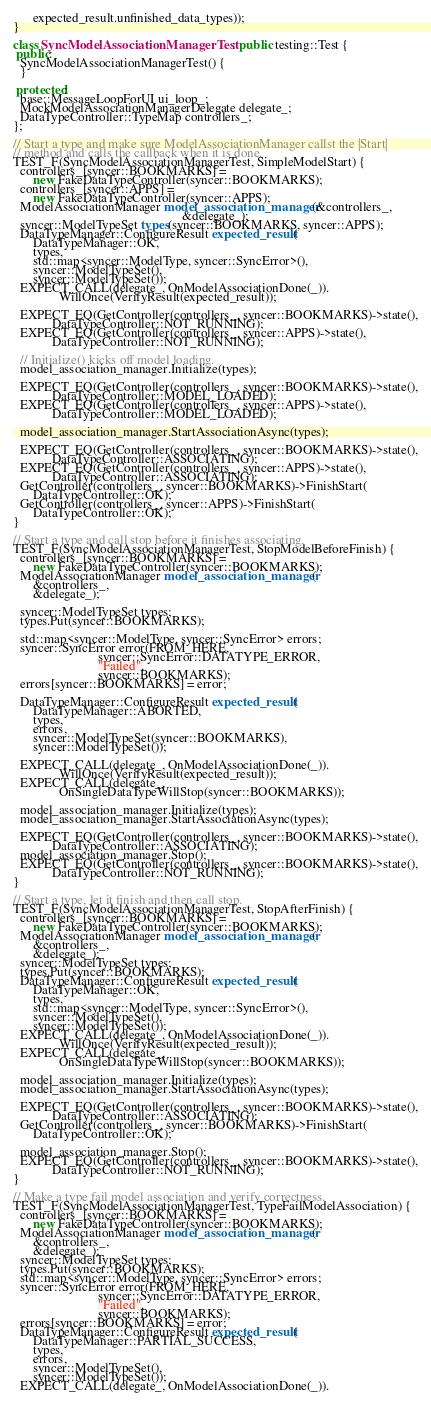Convert code to text. <code><loc_0><loc_0><loc_500><loc_500><_C++_>      expected_result.unfinished_data_types));
}

class SyncModelAssociationManagerTest : public testing::Test {
 public:
  SyncModelAssociationManagerTest() {
  }

 protected:
  base::MessageLoopForUI ui_loop_;
  MockModelAssociationManagerDelegate delegate_;
  DataTypeController::TypeMap controllers_;
};

// Start a type and make sure ModelAssociationManager callst the |Start|
// method and calls the callback when it is done.
TEST_F(SyncModelAssociationManagerTest, SimpleModelStart) {
  controllers_[syncer::BOOKMARKS] =
      new FakeDataTypeController(syncer::BOOKMARKS);
  controllers_[syncer::APPS] =
      new FakeDataTypeController(syncer::APPS);
  ModelAssociationManager model_association_manager(&controllers_,
                                                    &delegate_);
  syncer::ModelTypeSet types(syncer::BOOKMARKS, syncer::APPS);
  DataTypeManager::ConfigureResult expected_result(
      DataTypeManager::OK,
      types,
      std::map<syncer::ModelType, syncer::SyncError>(),
      syncer::ModelTypeSet(),
      syncer::ModelTypeSet());
  EXPECT_CALL(delegate_, OnModelAssociationDone(_)).
              WillOnce(VerifyResult(expected_result));

  EXPECT_EQ(GetController(controllers_, syncer::BOOKMARKS)->state(),
            DataTypeController::NOT_RUNNING);
  EXPECT_EQ(GetController(controllers_, syncer::APPS)->state(),
            DataTypeController::NOT_RUNNING);

  // Initialize() kicks off model loading.
  model_association_manager.Initialize(types);

  EXPECT_EQ(GetController(controllers_, syncer::BOOKMARKS)->state(),
            DataTypeController::MODEL_LOADED);
  EXPECT_EQ(GetController(controllers_, syncer::APPS)->state(),
            DataTypeController::MODEL_LOADED);

  model_association_manager.StartAssociationAsync(types);

  EXPECT_EQ(GetController(controllers_, syncer::BOOKMARKS)->state(),
            DataTypeController::ASSOCIATING);
  EXPECT_EQ(GetController(controllers_, syncer::APPS)->state(),
            DataTypeController::ASSOCIATING);
  GetController(controllers_, syncer::BOOKMARKS)->FinishStart(
      DataTypeController::OK);
  GetController(controllers_, syncer::APPS)->FinishStart(
      DataTypeController::OK);
}

// Start a type and call stop before it finishes associating.
TEST_F(SyncModelAssociationManagerTest, StopModelBeforeFinish) {
  controllers_[syncer::BOOKMARKS] =
      new FakeDataTypeController(syncer::BOOKMARKS);
  ModelAssociationManager model_association_manager(
      &controllers_,
      &delegate_);

  syncer::ModelTypeSet types;
  types.Put(syncer::BOOKMARKS);

  std::map<syncer::ModelType, syncer::SyncError> errors;
  syncer::SyncError error(FROM_HERE,
                          syncer::SyncError::DATATYPE_ERROR,
                          "Failed",
                          syncer::BOOKMARKS);
  errors[syncer::BOOKMARKS] = error;

  DataTypeManager::ConfigureResult expected_result(
      DataTypeManager::ABORTED,
      types,
      errors,
      syncer::ModelTypeSet(syncer::BOOKMARKS),
      syncer::ModelTypeSet());

  EXPECT_CALL(delegate_, OnModelAssociationDone(_)).
              WillOnce(VerifyResult(expected_result));
  EXPECT_CALL(delegate_,
              OnSingleDataTypeWillStop(syncer::BOOKMARKS));

  model_association_manager.Initialize(types);
  model_association_manager.StartAssociationAsync(types);

  EXPECT_EQ(GetController(controllers_, syncer::BOOKMARKS)->state(),
            DataTypeController::ASSOCIATING);
  model_association_manager.Stop();
  EXPECT_EQ(GetController(controllers_, syncer::BOOKMARKS)->state(),
            DataTypeController::NOT_RUNNING);
}

// Start a type, let it finish and then call stop.
TEST_F(SyncModelAssociationManagerTest, StopAfterFinish) {
  controllers_[syncer::BOOKMARKS] =
      new FakeDataTypeController(syncer::BOOKMARKS);
  ModelAssociationManager model_association_manager(
      &controllers_,
      &delegate_);
  syncer::ModelTypeSet types;
  types.Put(syncer::BOOKMARKS);
  DataTypeManager::ConfigureResult expected_result(
      DataTypeManager::OK,
      types,
      std::map<syncer::ModelType, syncer::SyncError>(),
      syncer::ModelTypeSet(),
      syncer::ModelTypeSet());
  EXPECT_CALL(delegate_, OnModelAssociationDone(_)).
              WillOnce(VerifyResult(expected_result));
  EXPECT_CALL(delegate_,
              OnSingleDataTypeWillStop(syncer::BOOKMARKS));

  model_association_manager.Initialize(types);
  model_association_manager.StartAssociationAsync(types);

  EXPECT_EQ(GetController(controllers_, syncer::BOOKMARKS)->state(),
            DataTypeController::ASSOCIATING);
  GetController(controllers_, syncer::BOOKMARKS)->FinishStart(
      DataTypeController::OK);

  model_association_manager.Stop();
  EXPECT_EQ(GetController(controllers_, syncer::BOOKMARKS)->state(),
            DataTypeController::NOT_RUNNING);
}

// Make a type fail model association and verify correctness.
TEST_F(SyncModelAssociationManagerTest, TypeFailModelAssociation) {
  controllers_[syncer::BOOKMARKS] =
      new FakeDataTypeController(syncer::BOOKMARKS);
  ModelAssociationManager model_association_manager(
      &controllers_,
      &delegate_);
  syncer::ModelTypeSet types;
  types.Put(syncer::BOOKMARKS);
  std::map<syncer::ModelType, syncer::SyncError> errors;
  syncer::SyncError error(FROM_HERE,
                          syncer::SyncError::DATATYPE_ERROR,
                          "Failed",
                          syncer::BOOKMARKS);
  errors[syncer::BOOKMARKS] = error;
  DataTypeManager::ConfigureResult expected_result(
      DataTypeManager::PARTIAL_SUCCESS,
      types,
      errors,
      syncer::ModelTypeSet(),
      syncer::ModelTypeSet());
  EXPECT_CALL(delegate_, OnModelAssociationDone(_)).</code> 